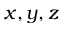Convert formula to latex. <formula><loc_0><loc_0><loc_500><loc_500>x , y , z</formula> 